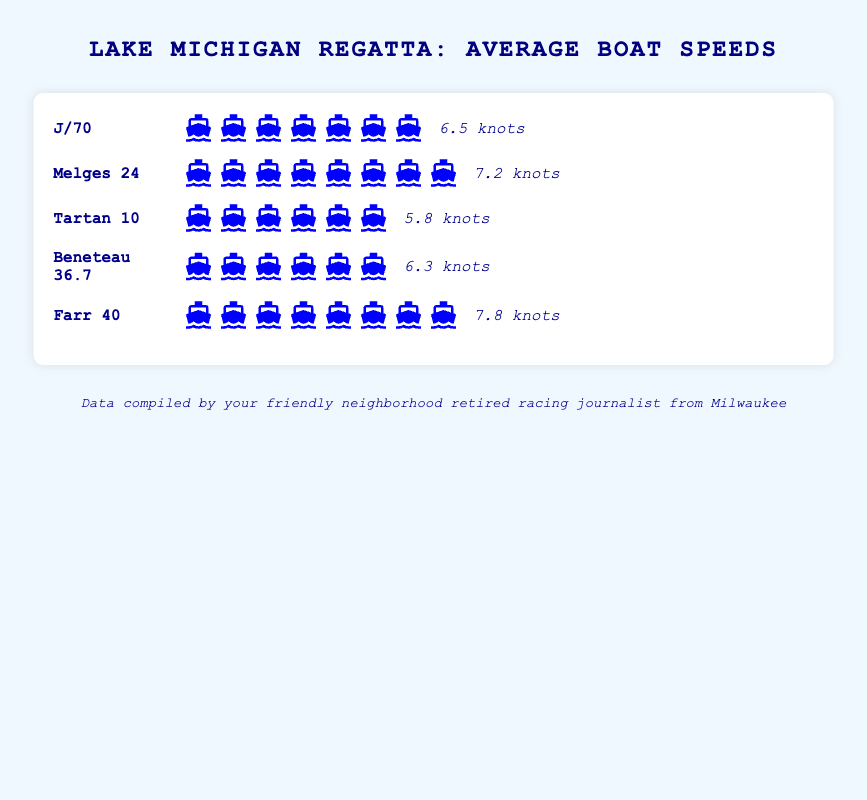What are the boat classes featured in the chart? The chart lists five different types of boats: J/70, Melges 24, Tartan 10, Beneteau 36.7, and Farr 40
Answer: J/70, Melges 24, Tartan 10, Beneteau 36.7, Farr 40 What is the average speed of the Melges 24 class? The speed is shown after the boat icons in the row labeled "Melges 24"
Answer: 7.2 knots Which boat class has the highest average speed? By comparing the average speeds listed for each boat class, the Farr 40 has the highest speed with 7.8 knots
Answer: Farr 40 How many boat icons represent the average speed for the J/70 class? Count the icons in the "J/70" row
Answer: 7 icons Which boat has the lowest average speed? By comparing the speeds listed on the chart, the Tartan 10 has the lowest speed with 5.8 knots
Answer: Tartan 10 What is the combined average speed of J/70 and Tartan 10 boats? Add the average speeds of J/70 (6.5 knots) and Tartan 10 (5.8 knots)
Answer: 12.3 knots How many classes have an average speed greater than 7 knots? Count the classes whose speeds, shown next to the boat icons, are greater than 7 knots (Melges 24 and Farr 40)
Answer: 2 classes Which class has more participants, J/70 or Beneteau 36.7, based on the icon representation? Compare the number of boat icons in the rows for J/70 and Beneteau 36.7
Answer: J/70 What is the average speed difference between the Melges 24 and the Beneteau 36.7? Subtract the speed of Beneteau 36.7 (6.3 knots) from the speed of Melges 24 (7.2 knots)
Answer: 0.9 knots Arrange the boat classes in ascending order of their average speed. List the classes by increasing average speed: Tartan 10 (5.8 knots), Beneteau 36.7 (6.3 knots), J/70 (6.5 knots), Melges 24 (7.2 knots), Farr 40 (7.8 knots)
Answer: Tartan 10, Beneteau 36.7, J/70, Melges 24, Farr 40 